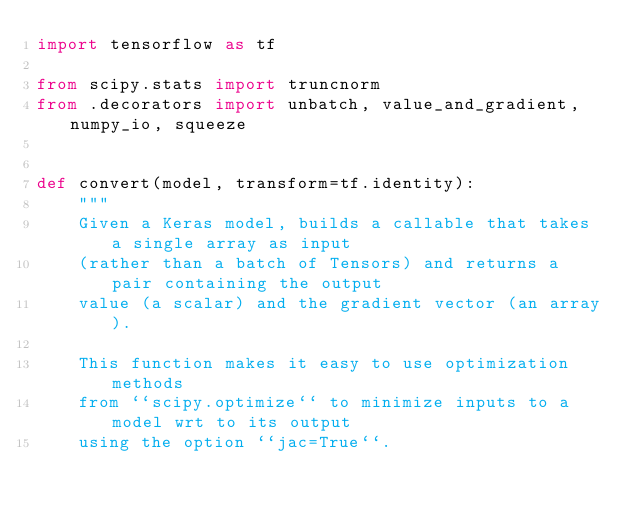Convert code to text. <code><loc_0><loc_0><loc_500><loc_500><_Python_>import tensorflow as tf

from scipy.stats import truncnorm
from .decorators import unbatch, value_and_gradient, numpy_io, squeeze


def convert(model, transform=tf.identity):
    """
    Given a Keras model, builds a callable that takes a single array as input
    (rather than a batch of Tensors) and returns a pair containing the output
    value (a scalar) and the gradient vector (an array).

    This function makes it easy to use optimization methods
    from ``scipy.optimize`` to minimize inputs to a model wrt to its output
    using the option ``jac=True``.
</code> 